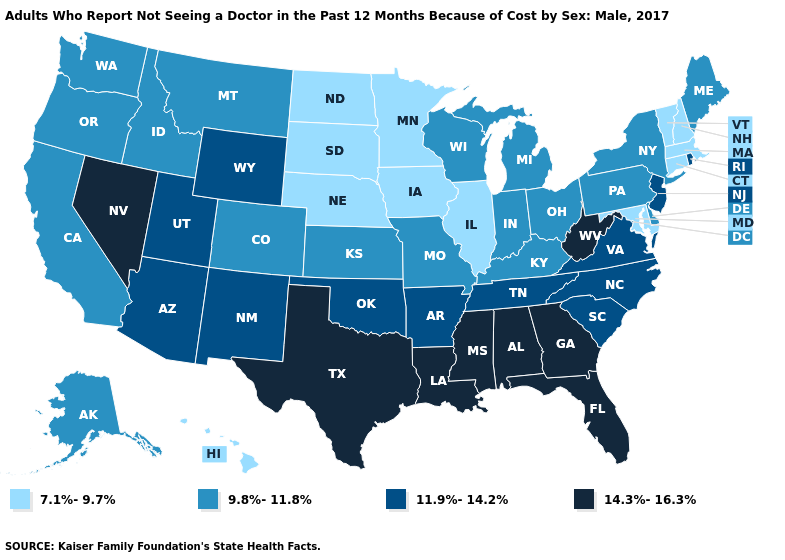What is the value of Louisiana?
Answer briefly. 14.3%-16.3%. What is the value of Connecticut?
Answer briefly. 7.1%-9.7%. Does New Jersey have the lowest value in the USA?
Quick response, please. No. Name the states that have a value in the range 14.3%-16.3%?
Give a very brief answer. Alabama, Florida, Georgia, Louisiana, Mississippi, Nevada, Texas, West Virginia. Does the first symbol in the legend represent the smallest category?
Be succinct. Yes. Among the states that border North Dakota , does Minnesota have the lowest value?
Write a very short answer. Yes. What is the lowest value in the MidWest?
Short answer required. 7.1%-9.7%. Name the states that have a value in the range 14.3%-16.3%?
Answer briefly. Alabama, Florida, Georgia, Louisiana, Mississippi, Nevada, Texas, West Virginia. Name the states that have a value in the range 11.9%-14.2%?
Give a very brief answer. Arizona, Arkansas, New Jersey, New Mexico, North Carolina, Oklahoma, Rhode Island, South Carolina, Tennessee, Utah, Virginia, Wyoming. Name the states that have a value in the range 14.3%-16.3%?
Concise answer only. Alabama, Florida, Georgia, Louisiana, Mississippi, Nevada, Texas, West Virginia. Name the states that have a value in the range 9.8%-11.8%?
Short answer required. Alaska, California, Colorado, Delaware, Idaho, Indiana, Kansas, Kentucky, Maine, Michigan, Missouri, Montana, New York, Ohio, Oregon, Pennsylvania, Washington, Wisconsin. Which states have the lowest value in the USA?
Write a very short answer. Connecticut, Hawaii, Illinois, Iowa, Maryland, Massachusetts, Minnesota, Nebraska, New Hampshire, North Dakota, South Dakota, Vermont. Name the states that have a value in the range 11.9%-14.2%?
Give a very brief answer. Arizona, Arkansas, New Jersey, New Mexico, North Carolina, Oklahoma, Rhode Island, South Carolina, Tennessee, Utah, Virginia, Wyoming. 